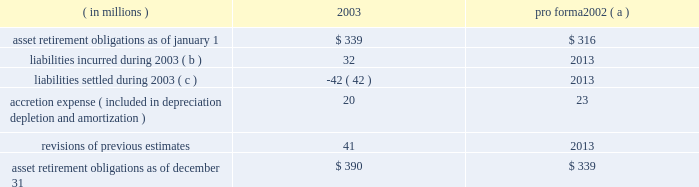New accounting standards effective january 1 , 2003 , marathon adopted statement of financial accounting standards no .
143 201caccounting for asset retirement obligations 201d ( 201csfas no .
143 201d ) .
This statement requires that the fair value of an asset retirement obligation be recognized in the period in which it is incurred if a reasonable estimate of fair value can be made .
The present value of the estimated asset retirement cost is capitalized as part of the carrying amount of the long-lived asset .
Previous accounting standards used the units-of-production method to match estimated future retirement costs with the revenues generated from the producing assets .
In contrast , sfas no .
143 requires depreciation of the capitalized asset retirement cost and accretion of the asset retirement obligation over time .
The depreciation will generally be determined on a units-of-production basis over the life of the field , while the accretion to be recognized will escalate over the life of the producing assets , typically as production declines .
For marathon , asset retirement obligations primarily relate to the abandonment of oil and gas producing facilities .
While assets such as refineries , crude oil and product pipelines , and marketing assets have retirement obligations covered by sfas no .
143 , certain of those obligations are not recognized since the fair value cannot be estimated due to the uncertainty of the settlement date of the obligation .
The transition adjustment related to adopting sfas no .
143 on january 1 , 2003 , was recognized as a cumulative effect of a change in accounting principle .
The cumulative effect on net income of adopting sfas no .
143 was a net favorable effect of $ 4 million , net of tax of $ 4 million .
At the time of adoption , total assets increased $ 120 million , and total liabilities increased $ 116 million .
The amounts recognized upon adoption are based upon numerous estimates and assumptions , including future retirement costs , future recoverable quantities of oil and gas , future inflation rates and the credit-adjusted risk-free interest rate .
Changes in asset retirement obligations during the year were : ( in millions ) 2003 pro forma 2002 ( a ) .
( a ) pro forma data as if sfas no .
143 had been adopted on january 1 , 2002 .
If adopted , income before cumulative effect of changes in accounting principles for 2002 would have been increased by $ 1 million and there would have been no impact on earnings per share .
( b ) includes $ 12 million related to the acquisition of khanty mansiysk oil corporation in 2003 .
( c ) includes $ 25 million associated with assets sold in 2003 .
In the second quarter of 2002 , the financial accounting standards board ( 201cfasb 201d ) issued statement of financial accounting standards no .
145 201crescission of fasb statements no .
4 , 44 , and 64 , amendment of fasb statement no .
13 , and technical corrections 201d ( 201csfas no .
145 201d ) .
Effective january 1 , 2003 , marathon adopted the provisions relating to the classification of the effects of early extinguishment of debt in the consolidated statement of income .
As a result , losses of $ 53 million from the early extinguishment of debt in 2002 , which were previously reported as an extraordinary item ( net of tax of $ 20 million ) , have been reclassified into income before income taxes .
The adoption of sfas no .
145 had no impact on net income for 2002 .
Effective january 1 , 2003 , marathon adopted statement of financial accounting standards no .
146 201caccounting for exit or disposal activities 201d ( 201csfas no .
146 201d ) .
Sfas no .
146 is effective for exit or disposal activities that are initiated after december 31 , 2002 .
There were no impacts upon the initial adoption of sfas no .
146 .
Effective january 1 , 2003 , marathon adopted the fair value recognition provisions of statement of financial accounting standards no .
123 201caccounting for stock-based compensation 201d ( 201csfas no .
123 201d ) .
Statement of financial accounting standards no .
148 201caccounting for stock-based compensation 2013 transition and disclosure 201d ( 201csfas no .
148 201d ) , an amendment of sfas no .
123 , provides alternative methods for the transition of the accounting for stock-based compensation from the intrinsic value method to the fair value method .
Marathon has applied the fair value method to grants made , modified or settled on or after january 1 , 2003 .
The impact on marathon 2019s 2003 net income was not materially different than under previous accounting standards .
The fasb issued statement of financial accounting standards no .
149 201camendment of statement 133 on derivative instruments and hedging activities 201d on april 30 , 2003 .
The statement is effective for derivative contracts entered into or modified after june 30 , 2003 and for hedging relationships designated after june 30 , 2003 .
The adoption of this statement did not have an effect on marathon 2019s financial position , cash flows or results of operations .
The fasb issued statement of financial accounting standards no .
150 201caccounting for certain financial instruments with characteristics of both liabilities and equity 201d on may 30 , 2003 .
The adoption of this statement , effective july 1 , 2003 , did not have a material effect on marathon 2019s financial position or results of operations .
Effective january 1 , 2003 , fasb interpretation no .
45 , 201cguarantor 2019s accounting and disclosure requirements for guarantees , including indirect guarantees of indebtedness of others 201d ( 201cfin 45 201d ) , requires the fair-value .
What are the average asset retirement obligations as of january 1 2002 and 2003 in millions? 
Computations: table_average(asset retirement obligations as of january 1, none)
Answer: 327.5. 